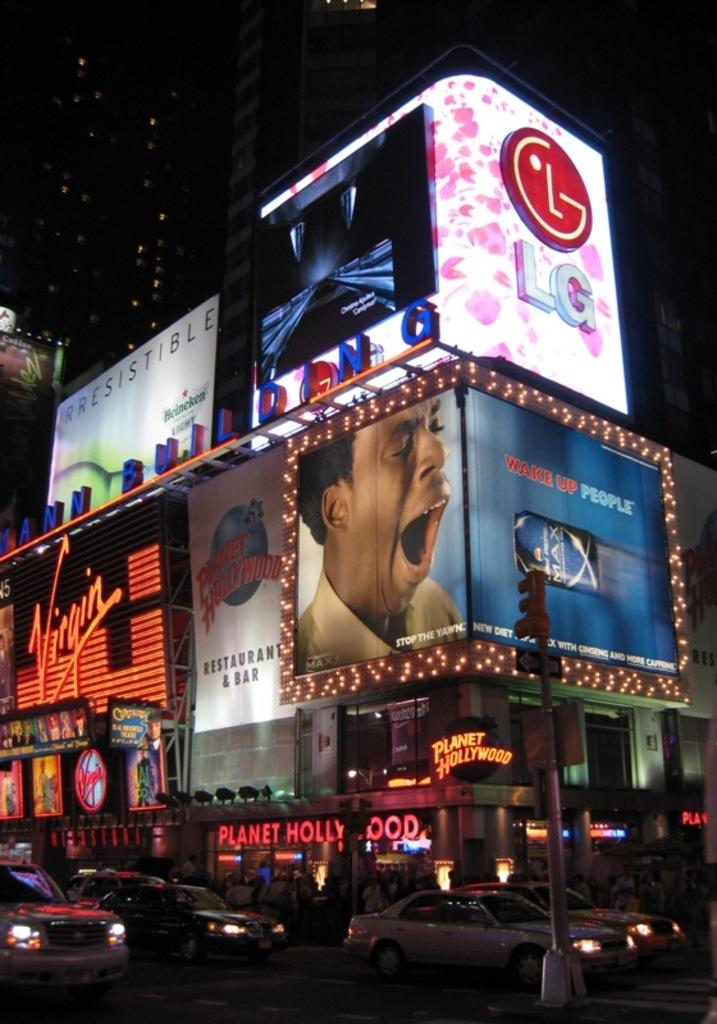<image>
Provide a brief description of the given image. A Planet Hollywood building is lit up at night with ads for many products. 